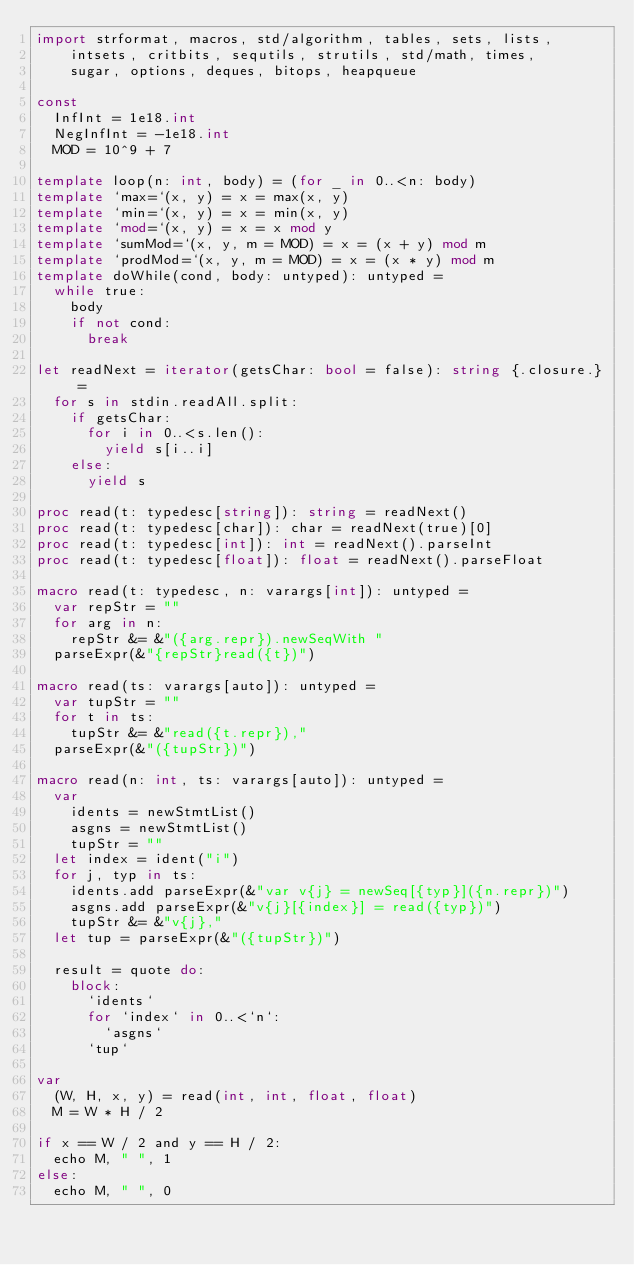Convert code to text. <code><loc_0><loc_0><loc_500><loc_500><_Nim_>import strformat, macros, std/algorithm, tables, sets, lists,
    intsets, critbits, sequtils, strutils, std/math, times,
    sugar, options, deques, bitops, heapqueue

const
  InfInt = 1e18.int
  NegInfInt = -1e18.int
  MOD = 10^9 + 7

template loop(n: int, body) = (for _ in 0..<n: body)
template `max=`(x, y) = x = max(x, y)
template `min=`(x, y) = x = min(x, y)
template `mod=`(x, y) = x = x mod y
template `sumMod=`(x, y, m = MOD) = x = (x + y) mod m
template `prodMod=`(x, y, m = MOD) = x = (x * y) mod m
template doWhile(cond, body: untyped): untyped =
  while true:
    body
    if not cond:
      break

let readNext = iterator(getsChar: bool = false): string {.closure.} =
  for s in stdin.readAll.split:
    if getsChar:
      for i in 0..<s.len():
        yield s[i..i]
    else:
      yield s

proc read(t: typedesc[string]): string = readNext()
proc read(t: typedesc[char]): char = readNext(true)[0]
proc read(t: typedesc[int]): int = readNext().parseInt
proc read(t: typedesc[float]): float = readNext().parseFloat

macro read(t: typedesc, n: varargs[int]): untyped =
  var repStr = ""
  for arg in n:
    repStr &= &"({arg.repr}).newSeqWith "
  parseExpr(&"{repStr}read({t})")

macro read(ts: varargs[auto]): untyped =
  var tupStr = ""
  for t in ts:
    tupStr &= &"read({t.repr}),"
  parseExpr(&"({tupStr})")

macro read(n: int, ts: varargs[auto]): untyped =
  var
    idents = newStmtList()
    asgns = newStmtList()
    tupStr = ""
  let index = ident("i")
  for j, typ in ts:
    idents.add parseExpr(&"var v{j} = newSeq[{typ}]({n.repr})")
    asgns.add parseExpr(&"v{j}[{index}] = read({typ})")
    tupStr &= &"v{j},"
  let tup = parseExpr(&"({tupStr})")

  result = quote do:
    block:
      `idents`
      for `index` in 0..<`n`:
        `asgns`
      `tup`

var
  (W, H, x, y) = read(int, int, float, float)
  M = W * H / 2

if x == W / 2 and y == H / 2:
  echo M, " ", 1
else:
  echo M, " ", 0
</code> 